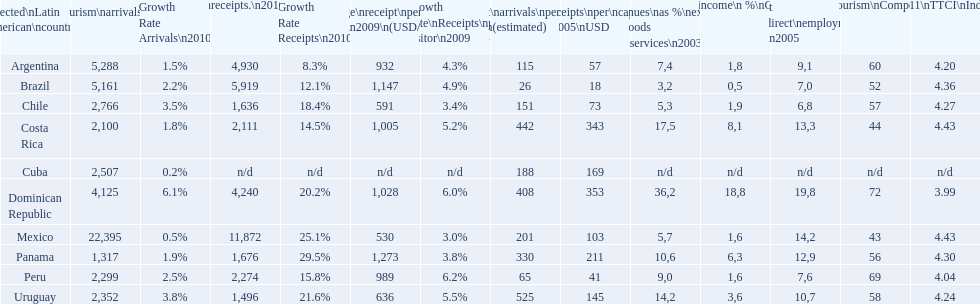What country had the least arrivals per 1000 inhabitants in 2007(estimated)? Brazil. 